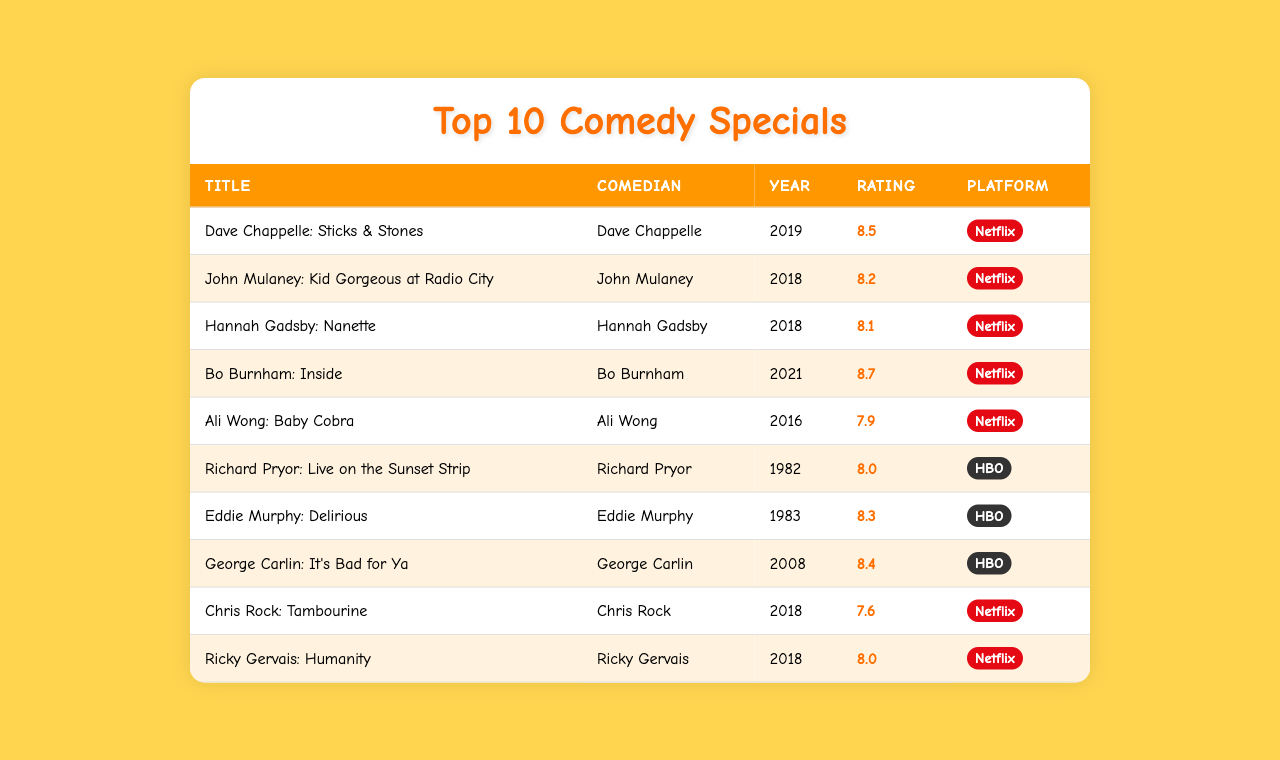What is the title of the comedy special with the highest viewer rating? The table shows the viewer ratings for each special, and "Bo Burnham: Inside" has the highest rating of 8.7.
Answer: Bo Burnham: Inside How many comedy specials were released in 2018? The table lists three specials from 2018: "John Mulaney: Kid Gorgeous at Radio City," "Hannah Gadsby: Nanette," and "Chris Rock: Tambourine."
Answer: 3 Which platform has more comedy specials listed? There are 6 specials from Netflix and 4 from HBO, so Netflix has more specials.
Answer: Netflix What is the average viewer rating of the comedy specials? The individual ratings are summed up (8.5 + 8.2 + 8.1 + 8.7 + 7.9 + 8.0 + 8.3 + 8.4 + 7.6 + 8.0) which totals 82.7, and dividing by 10 gives an average of 8.27.
Answer: 8.27 Is "Ali Wong: Baby Cobra" rated higher than "Chris Rock: Tambourine"? "Ali Wong: Baby Cobra" has a rating of 7.9 while "Chris Rock: Tambourine" has a rating of 7.6, which means Ali Wong's special is indeed rated higher.
Answer: Yes How many comedy specials have viewer ratings of 8.0 or higher? The ratings of 8.0 or higher belong to "Dave Chappelle: Sticks & Stones," "John Mulaney: Kid Gorgeous at Radio City," "Hannah Gadsby: Nanette," "Bo Burnham: Inside," "Richard Pryor: Live on the Sunset Strip," "Eddie Murphy: Delirious," and "George Carlin: It's Bad for Ya," totaling 7 specials.
Answer: 7 Which comedian has a special that was released in 1982? Looking at the table, "Richard Pryor: Live on the Sunset Strip" was released in 1982, indicating it's by comedian Richard Pryor.
Answer: Richard Pryor What is the difference in viewer ratings between "Bo Burnham: Inside" and "Ali Wong: Baby Cobra"? The ratings show 8.7 for "Bo Burnham: Inside" and 7.9 for "Ali Wong: Baby Cobra." Calculating the difference, 8.7 - 7.9 equals 0.8.
Answer: 0.8 Are there any comedy specials with the year 2021? Yes, examining the table reveals "Bo Burnham: Inside" was released in 2021.
Answer: Yes Which comedy special has the lowest viewer rating and what is that rating? The lowest rating is for "Chris Rock: Tambourine," which has a viewer rating of 7.6.
Answer: Chris Rock: Tambourine, 7.6 